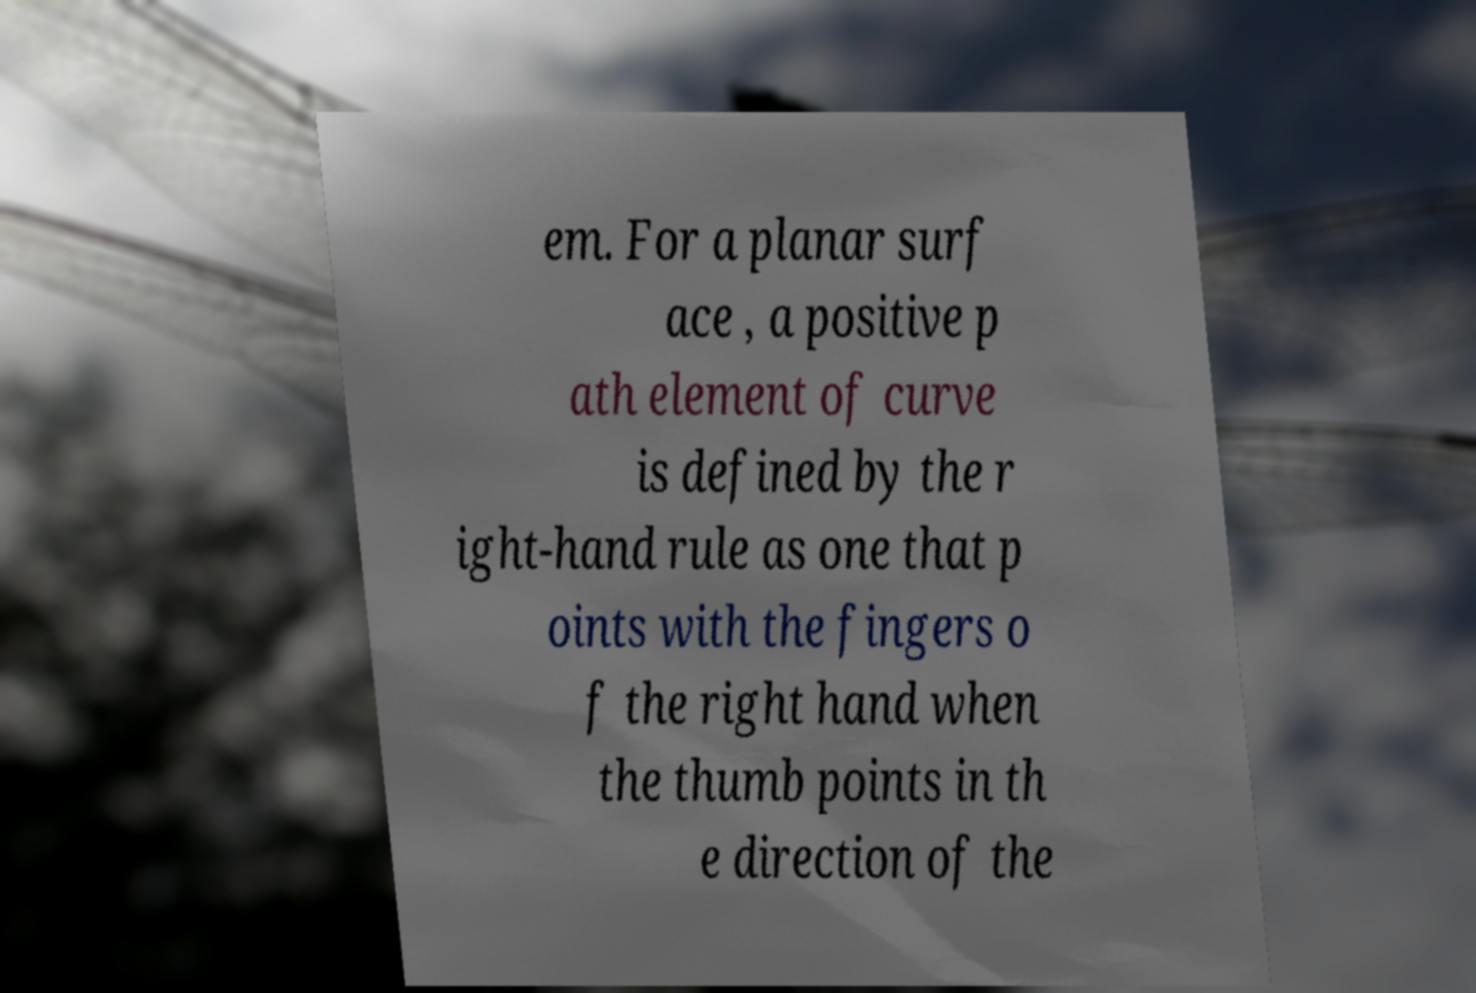There's text embedded in this image that I need extracted. Can you transcribe it verbatim? em. For a planar surf ace , a positive p ath element of curve is defined by the r ight-hand rule as one that p oints with the fingers o f the right hand when the thumb points in th e direction of the 